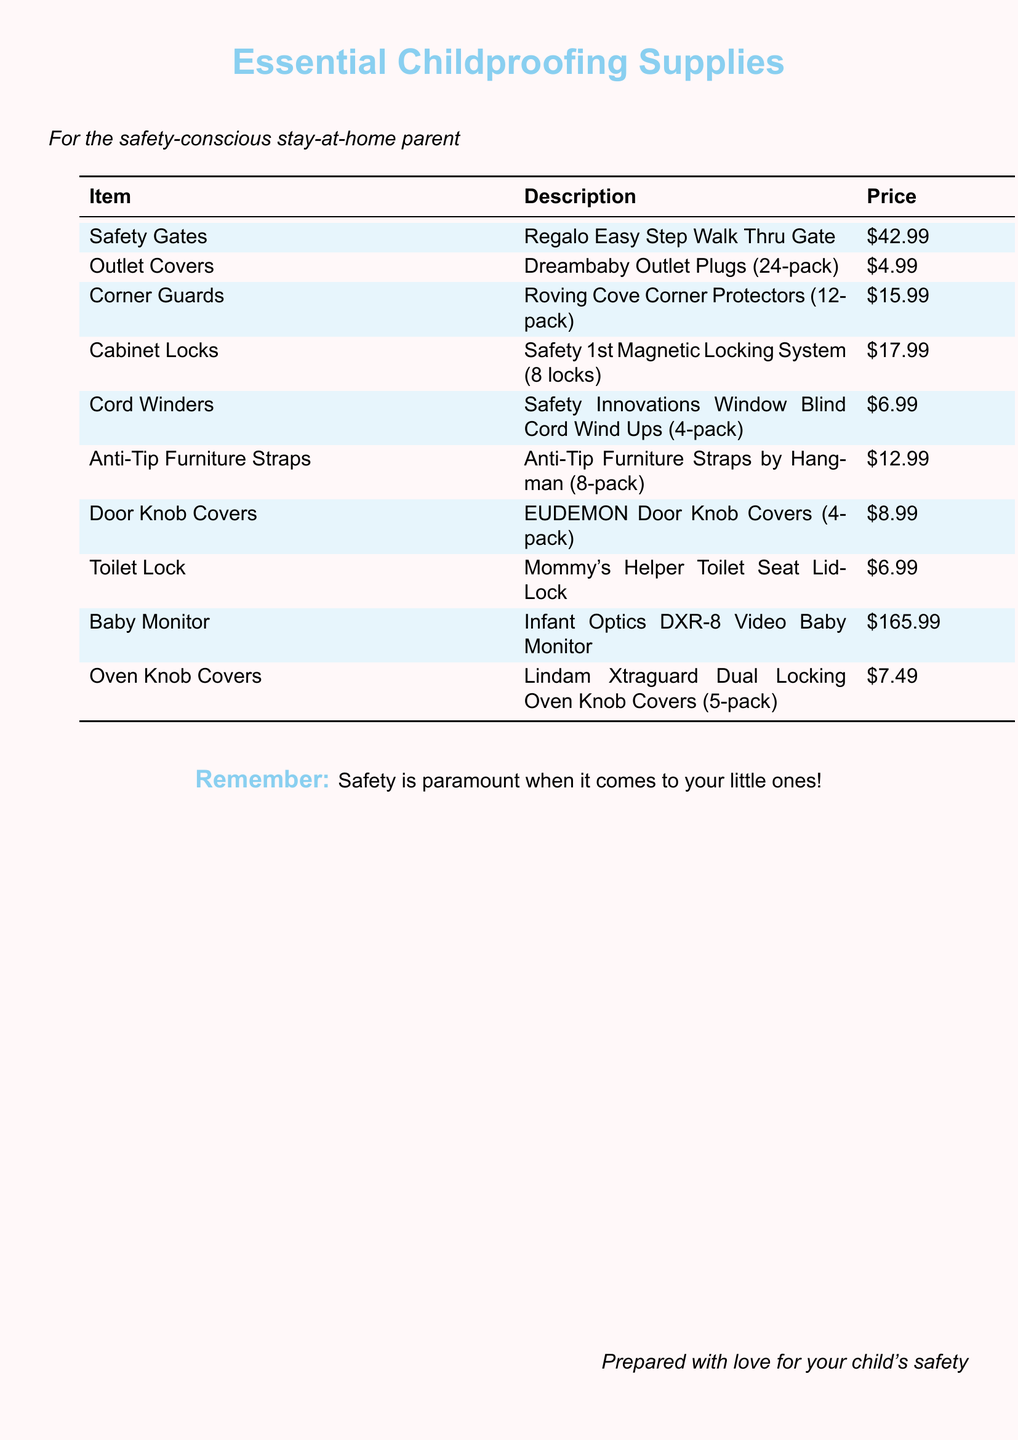What is the price of the Safety Gates? The price of the Safety Gates can be found in the price column, which is $42.99.
Answer: $42.99 How many Outlet Covers are included in one pack? The number of Outlet Covers is mentioned in the description for Outlet Covers, which states there are 24 plugs in a pack.
Answer: 24 What is the total price of Corner Guards and Cabinet Locks? To find the total, sum the prices of both items: $15.99 (Corner Guards) + $17.99 (Cabinet Locks) = $33.98.
Answer: $33.98 Which item is priced at $6.99? The price of $6.99 corresponds to both the Toilet Lock and Cord Winders listed in the document.
Answer: Toilet Lock / Cord Winders How many items are in the baby monitor? The Baby Monitor entry does not specify an item count like others; it is a single unit of a video baby monitor.
Answer: 1 Which color is used for the background of the document? The background color is described in the document as baby pink, indicating the overall theme color used.
Answer: baby pink What is the item listed for oven safety? The item pertaining to oven safety is Lindam Xtraguard Dual Locking Oven Knob Covers.
Answer: Lindam Xtraguard Dual Locking Oven Knob Covers How many pieces are included in the Anti-Tip Furniture Straps pack? The description for the Anti-Tip Furniture Straps indicates there are 8 straps included in the pack.
Answer: 8 What supplies are mentioned for cord management? The document lists Safety Innovations Window Blind Cord Wind Ups as the supply for cord management.
Answer: Safety Innovations Window Blind Cord Wind Ups 